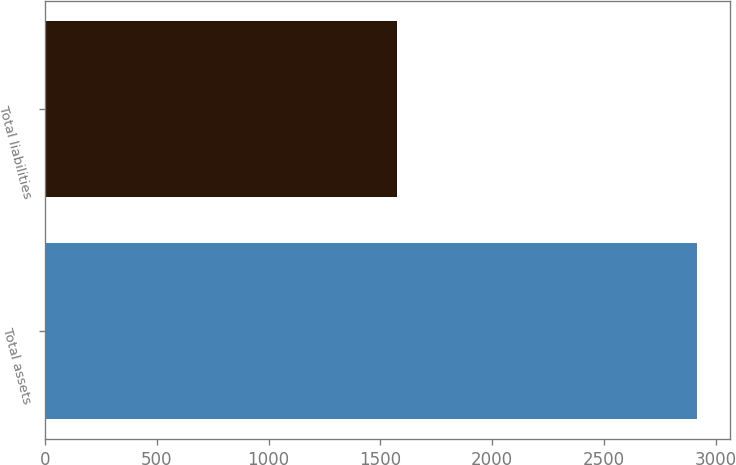Convert chart to OTSL. <chart><loc_0><loc_0><loc_500><loc_500><bar_chart><fcel>Total assets<fcel>Total liabilities<nl><fcel>2916<fcel>1576<nl></chart> 